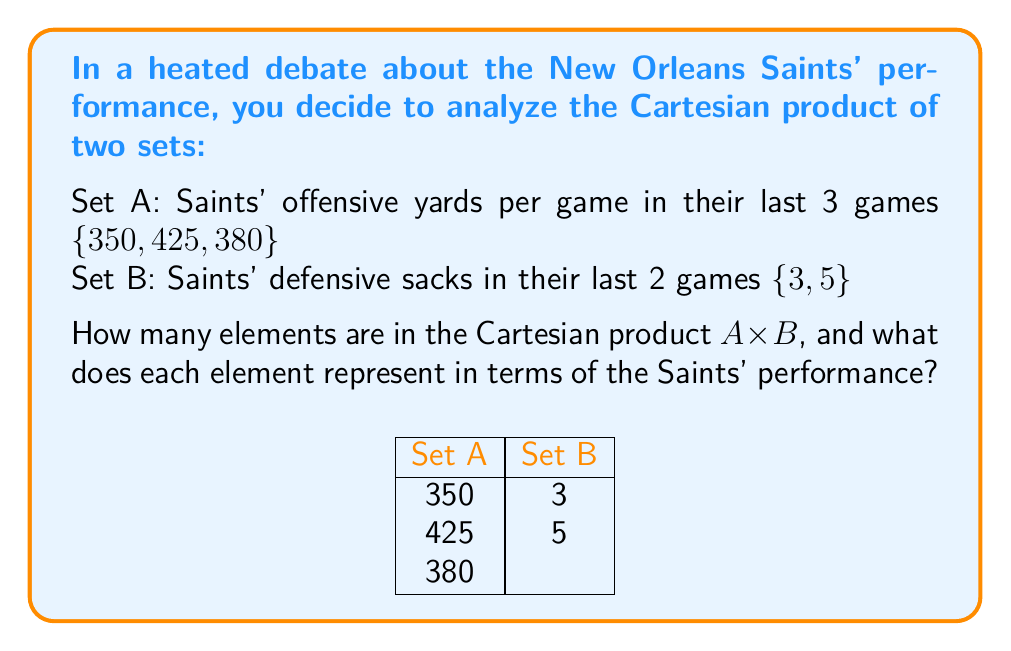Give your solution to this math problem. Let's break this down step-by-step:

1) The Cartesian product A × B is defined as the set of all ordered pairs (a, b) where a ∈ A and b ∈ B.

2) To find the number of elements in A × B, we multiply the number of elements in A by the number of elements in B:
   |A × B| = |A| × |B| = 3 × 2 = 6

3) The elements of A × B are:
   A × B = {(350, 3), (350, 5), (425, 3), (425, 5), (380, 3), (380, 5)}

4) Each element represents a potential combination of offensive yards and defensive sacks from different games. For example:
   (350, 3) represents a game with 350 offensive yards and 3 defensive sacks
   (425, 5) represents a game with 425 offensive yards and 5 defensive sacks

5) This Cartesian product allows us to consider all possible combinations of offensive and defensive performance from these games, which could be useful for analyzing trends or discussing "what if" scenarios in a debate about the Saints' overall performance.
Answer: 6 elements; each represents a combination of offensive yards and defensive sacks 